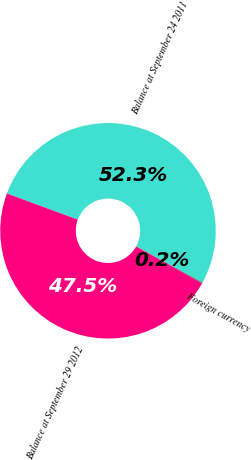Convert chart to OTSL. <chart><loc_0><loc_0><loc_500><loc_500><pie_chart><fcel>Balance at September 24 2011<fcel>Foreign currency<fcel>Balance at September 29 2012<nl><fcel>52.3%<fcel>0.16%<fcel>47.54%<nl></chart> 